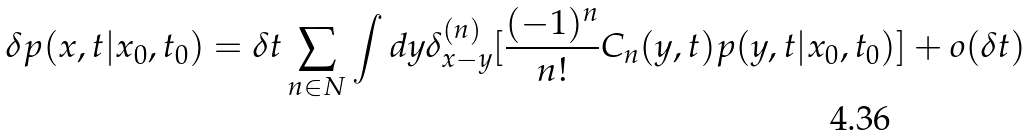Convert formula to latex. <formula><loc_0><loc_0><loc_500><loc_500>\delta p ( x , t | x _ { 0 } , t _ { 0 } ) = \delta t \sum _ { n \in N } \int { d y } \delta _ { x - y } ^ { ( n ) } [ { \frac { ( - 1 ) ^ { n } } { n ! } } C _ { n } ( y , t ) p ( y , t | x _ { 0 } , t _ { 0 } ) ] + o ( \delta t )</formula> 